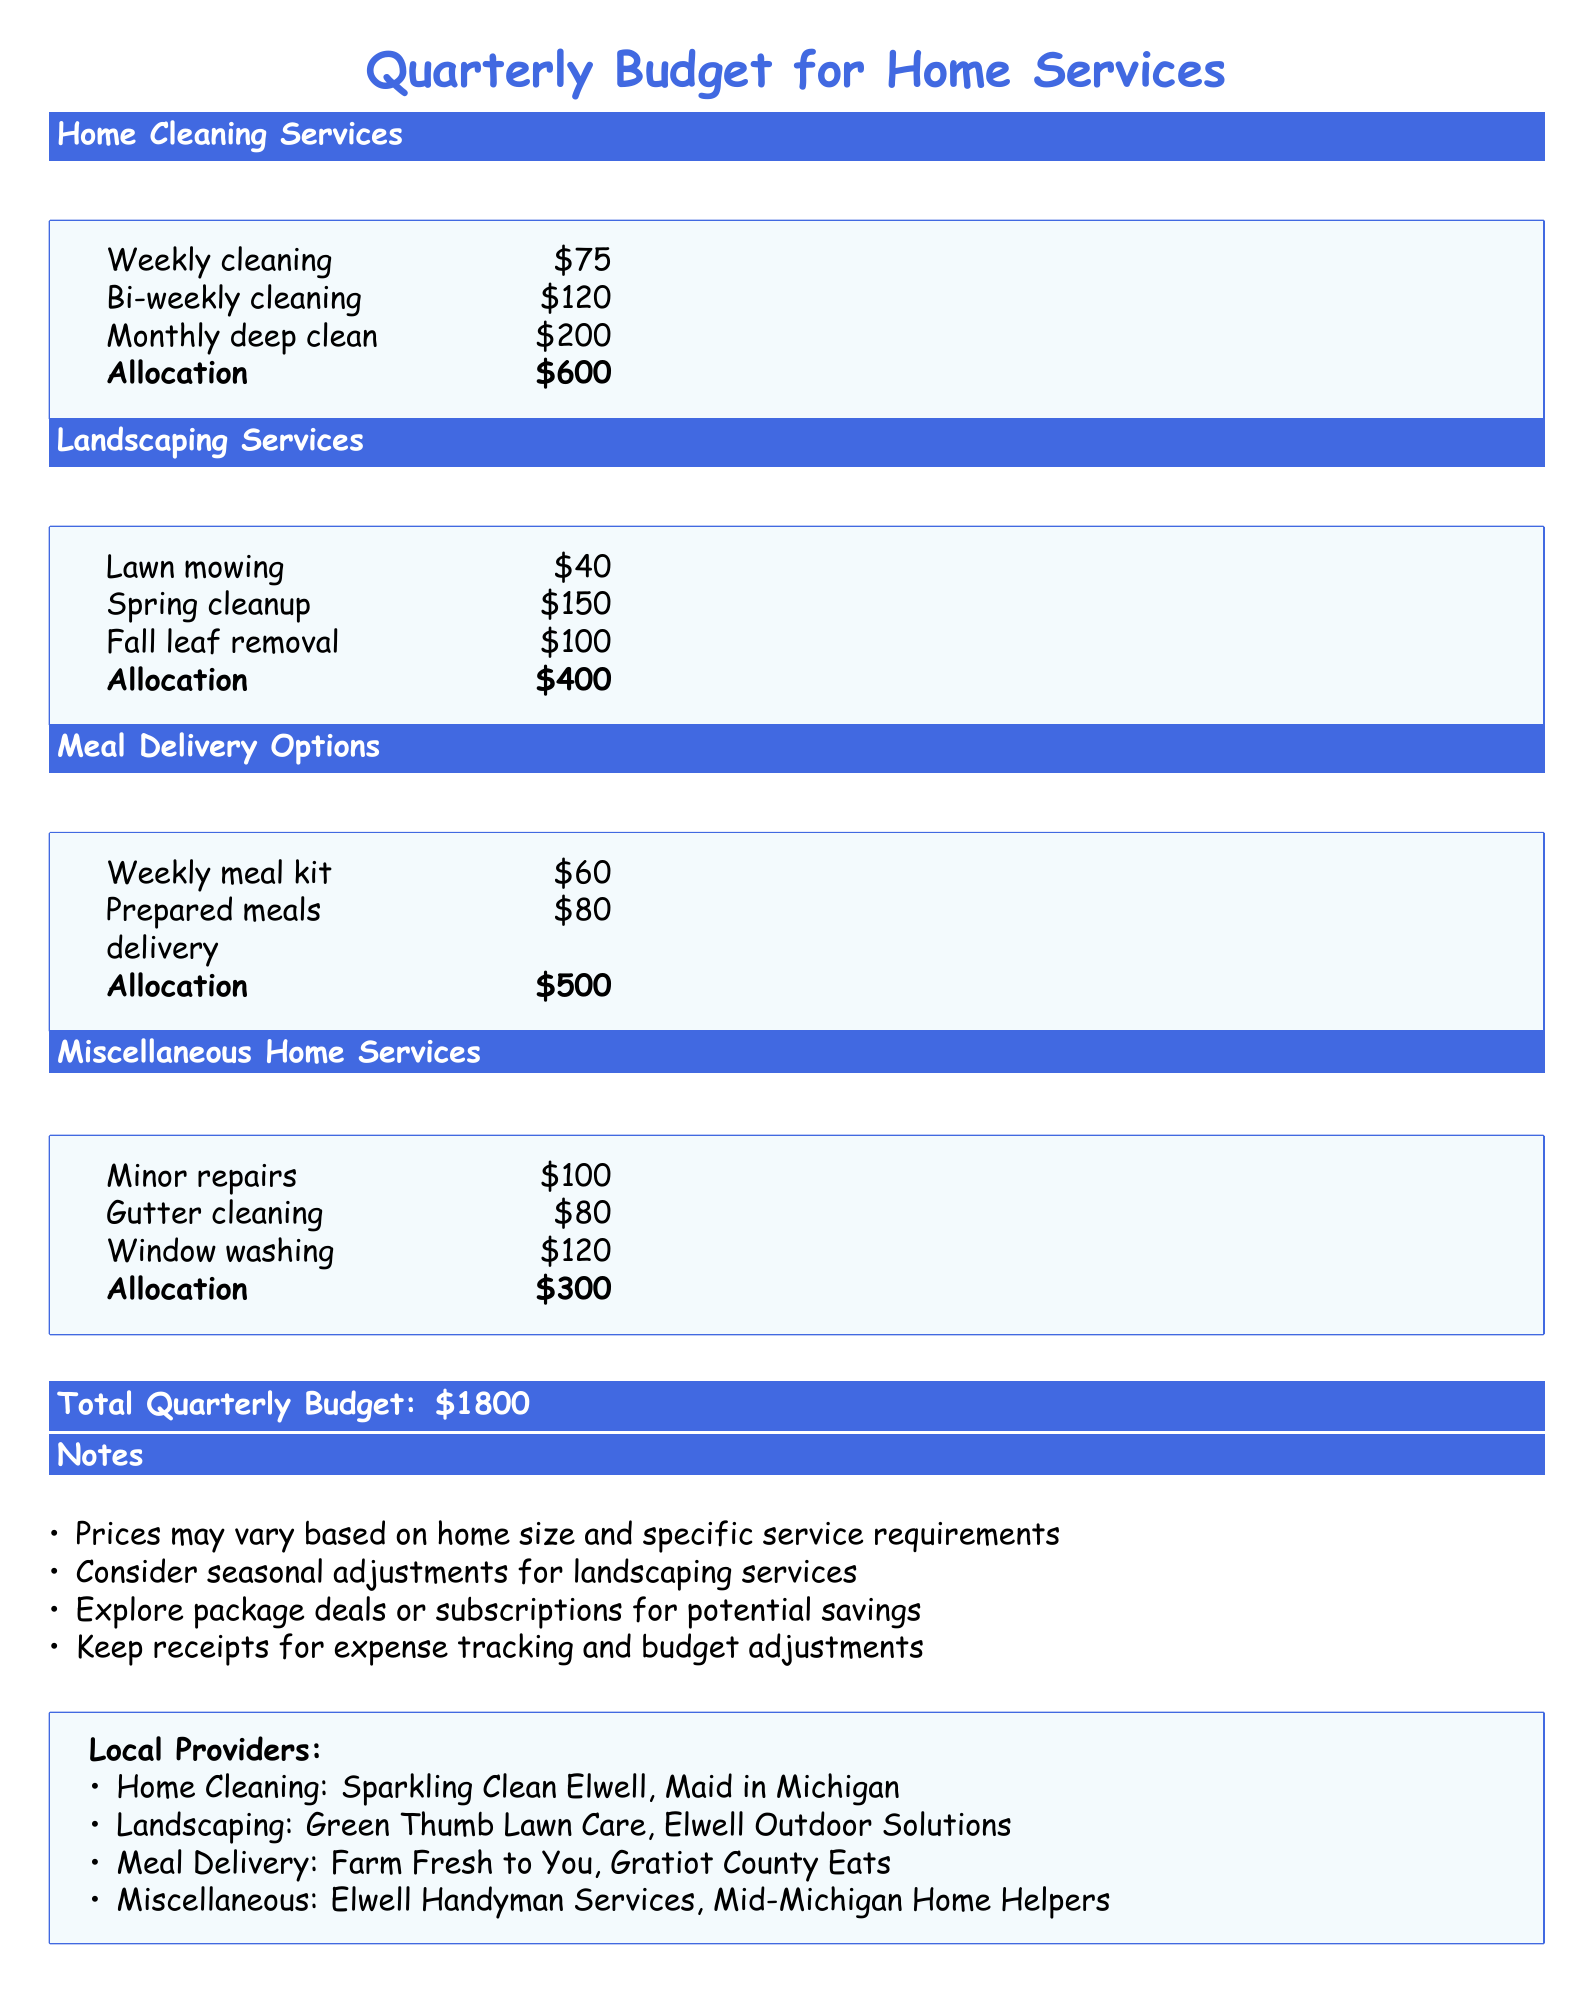What is the total budget allocated for home cleaning services? The total allocation for home cleaning services is specified in the budget table, which is $600.
Answer: $600 How much does weekly meal kit delivery cost? The price for a weekly meal kit is listed in the meal delivery options section of the document, which is $60.
Answer: $60 What is the cost of lawn mowing service? The budget document specifies that the cost of lawn mowing is $40.
Answer: $40 What service costs the most in the miscellaneous home services category? The highest cost in the miscellaneous home services section is for window washing at $120.
Answer: $120 What is the total quarterly budget amount? The total quarterly budget is clearly stated at the end of the document as $1800.
Answer: $1800 How many local providers are listed for meal delivery? The document provides the name of two local meal delivery providers under the Local Providers section.
Answer: 2 What home service has the least allocated budget? The service with the least allocation in the document is gutter cleaning, which has a budget of $80.
Answer: $80 What is the cost for a monthly deep clean? The cost for a monthly deep clean is provided in the home cleaning services section as $200.
Answer: $200 Which local provider offers landscaping services? The document lists two local landscaping providers, which includes Green Thumb Lawn Care.
Answer: Green Thumb Lawn Care 